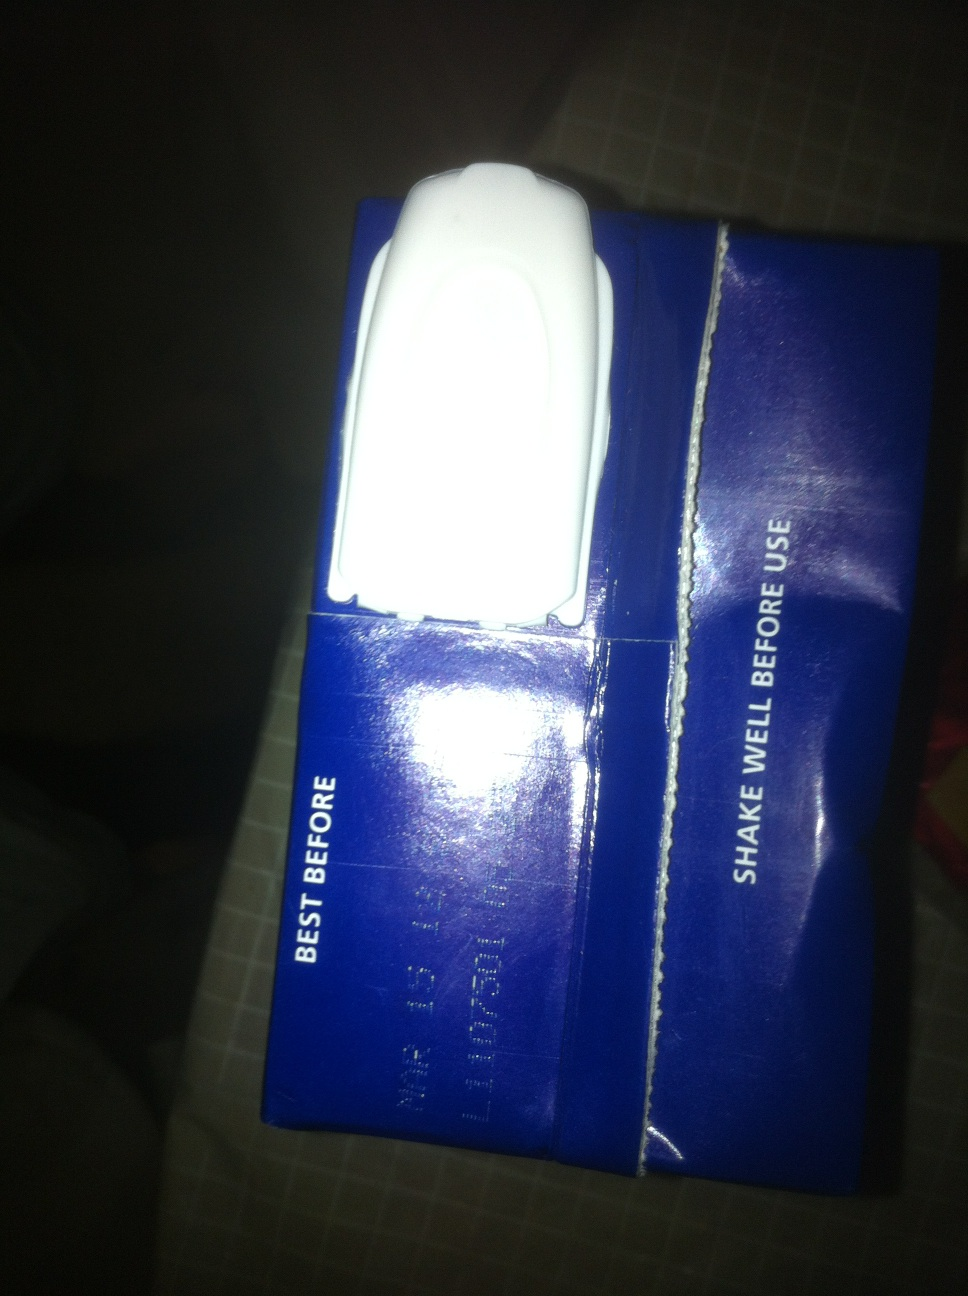Has the packaging been damaged in any way that could affect the product? There is visible damage along the edge and the central seal of the package, which could potentially compromise the product's integrity and freshness. It's advisable to inspect the seal and avoid usage if leakage or spoilage is suspected. 